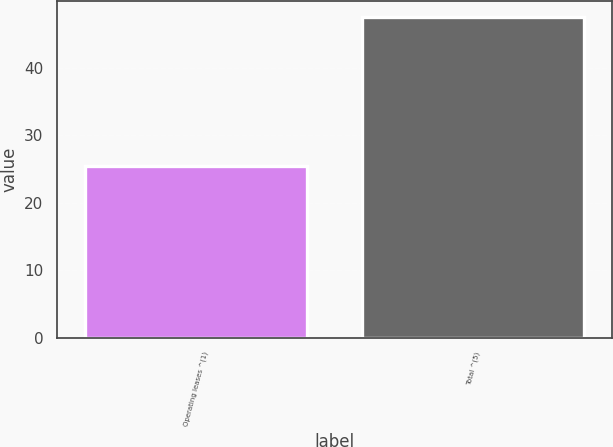Convert chart to OTSL. <chart><loc_0><loc_0><loc_500><loc_500><bar_chart><fcel>Operating leases ^(1)<fcel>Total ^(5)<nl><fcel>25.4<fcel>47.5<nl></chart> 